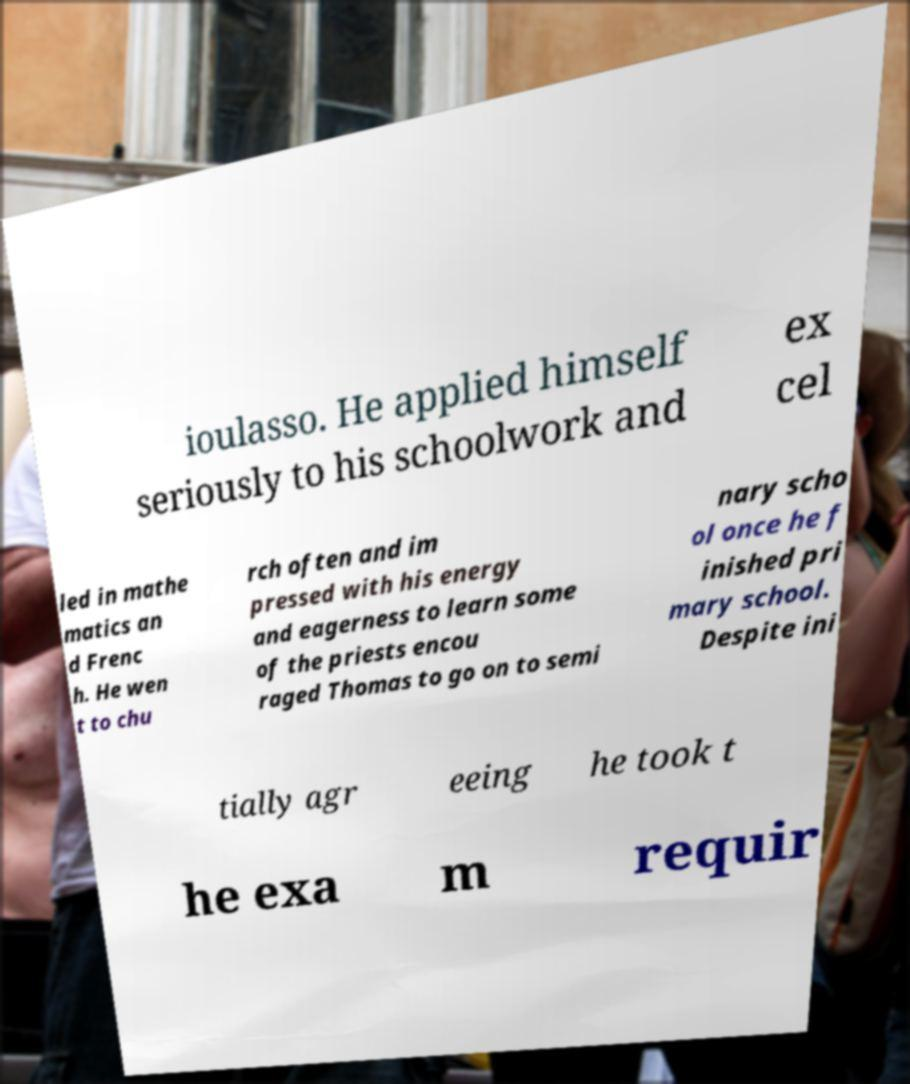What messages or text are displayed in this image? I need them in a readable, typed format. ioulasso. He applied himself seriously to his schoolwork and ex cel led in mathe matics an d Frenc h. He wen t to chu rch often and im pressed with his energy and eagerness to learn some of the priests encou raged Thomas to go on to semi nary scho ol once he f inished pri mary school. Despite ini tially agr eeing he took t he exa m requir 